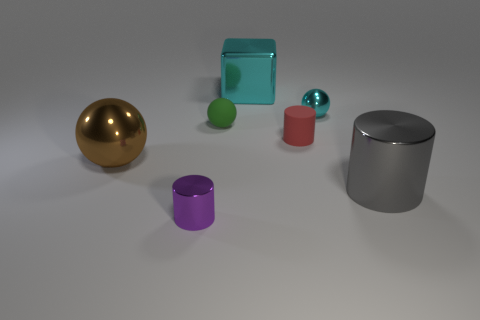Add 2 gray shiny things. How many objects exist? 9 Subtract all cubes. How many objects are left? 6 Add 3 tiny things. How many tiny things exist? 7 Subtract 0 yellow cubes. How many objects are left? 7 Subtract all blocks. Subtract all large cyan shiny objects. How many objects are left? 5 Add 5 big gray cylinders. How many big gray cylinders are left? 6 